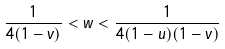<formula> <loc_0><loc_0><loc_500><loc_500>\frac { 1 } { 4 ( 1 - v ) } < w < \frac { 1 } { 4 ( 1 - u ) ( 1 - v ) }</formula> 